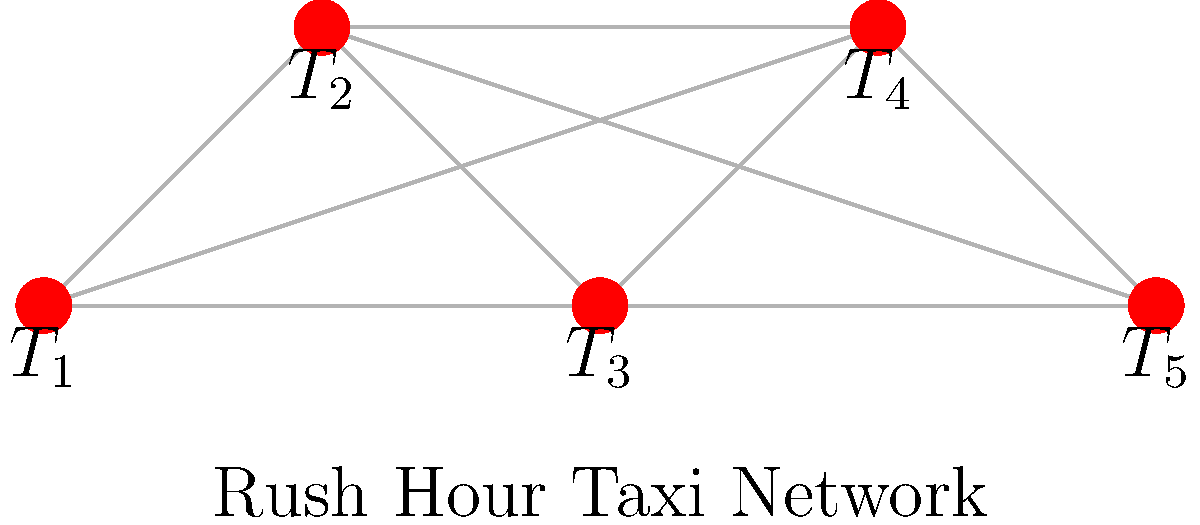In the rush hour taxi network shown above, each node represents a popular destination (T1 to T5), and edges represent direct routes between them. If a taxi driver wants to minimize the number of stops while visiting all destinations, what is the minimum number of edges they need to traverse? To solve this problem, we need to find the minimum spanning tree of the given graph. Here's how we can approach it:

1. The graph is complete, meaning every node is connected to every other node.
2. In a complete graph with $n$ vertices, the minimum spanning tree always has $n-1$ edges.
3. This is because we need to connect all vertices with the minimum number of edges, and $n-1$ edges are sufficient and necessary to connect $n$ vertices without forming a cycle.
4. In our graph, we have 5 vertices (T1 to T5).
5. Therefore, the minimum number of edges needed to visit all destinations is $5-1 = 4$.

This solution ensures that the taxi driver visits all destinations (nodes) while minimizing the number of direct routes (edges) traversed, which corresponds to minimizing the number of stops.
Answer: 4 edges 